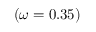<formula> <loc_0><loc_0><loc_500><loc_500>( \omega = 0 . 3 5 )</formula> 